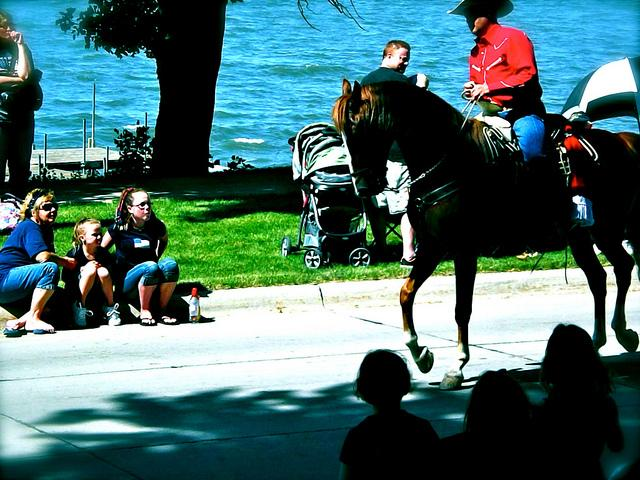The Horse and rider here are part of what?

Choices:
A) runaway horse
B) parade
C) rodeo roundup
D) escape parade 